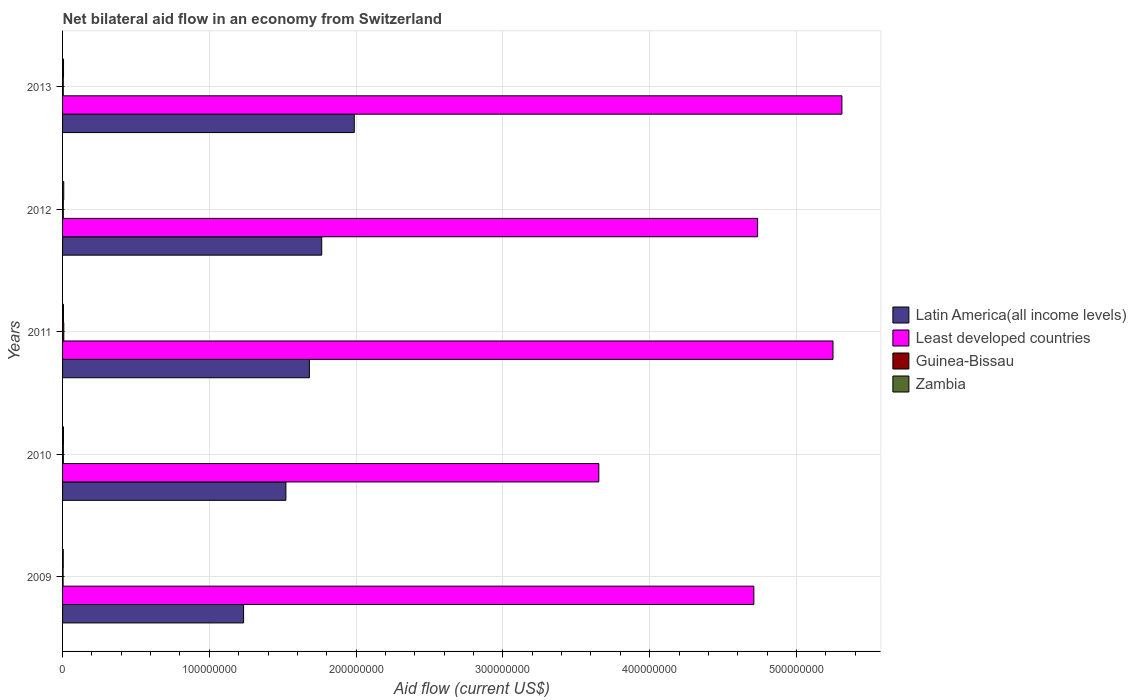How many groups of bars are there?
Your answer should be very brief. 5. Are the number of bars per tick equal to the number of legend labels?
Your answer should be compact. Yes. How many bars are there on the 5th tick from the top?
Keep it short and to the point. 4. How many bars are there on the 1st tick from the bottom?
Provide a short and direct response. 4. What is the label of the 1st group of bars from the top?
Provide a succinct answer. 2013. What is the net bilateral aid flow in Least developed countries in 2009?
Provide a succinct answer. 4.71e+08. Across all years, what is the maximum net bilateral aid flow in Zambia?
Keep it short and to the point. 8.10e+05. Across all years, what is the minimum net bilateral aid flow in Least developed countries?
Give a very brief answer. 3.65e+08. In which year was the net bilateral aid flow in Least developed countries maximum?
Ensure brevity in your answer.  2013. What is the total net bilateral aid flow in Latin America(all income levels) in the graph?
Your response must be concise. 8.19e+08. What is the difference between the net bilateral aid flow in Least developed countries in 2009 and that in 2010?
Keep it short and to the point. 1.06e+08. What is the difference between the net bilateral aid flow in Guinea-Bissau in 2011 and the net bilateral aid flow in Latin America(all income levels) in 2012?
Offer a terse response. -1.76e+08. What is the average net bilateral aid flow in Least developed countries per year?
Offer a very short reply. 4.73e+08. In the year 2009, what is the difference between the net bilateral aid flow in Least developed countries and net bilateral aid flow in Zambia?
Your answer should be compact. 4.71e+08. In how many years, is the net bilateral aid flow in Least developed countries greater than 120000000 US$?
Keep it short and to the point. 5. What is the ratio of the net bilateral aid flow in Latin America(all income levels) in 2009 to that in 2013?
Make the answer very short. 0.62. Is the net bilateral aid flow in Zambia in 2012 less than that in 2013?
Offer a terse response. No. Is the difference between the net bilateral aid flow in Least developed countries in 2010 and 2012 greater than the difference between the net bilateral aid flow in Zambia in 2010 and 2012?
Provide a short and direct response. No. What is the difference between the highest and the second highest net bilateral aid flow in Guinea-Bissau?
Provide a succinct answer. 3.10e+05. In how many years, is the net bilateral aid flow in Latin America(all income levels) greater than the average net bilateral aid flow in Latin America(all income levels) taken over all years?
Provide a short and direct response. 3. Is the sum of the net bilateral aid flow in Least developed countries in 2009 and 2010 greater than the maximum net bilateral aid flow in Guinea-Bissau across all years?
Provide a succinct answer. Yes. Is it the case that in every year, the sum of the net bilateral aid flow in Latin America(all income levels) and net bilateral aid flow in Zambia is greater than the sum of net bilateral aid flow in Guinea-Bissau and net bilateral aid flow in Least developed countries?
Ensure brevity in your answer.  Yes. What does the 4th bar from the top in 2010 represents?
Ensure brevity in your answer.  Latin America(all income levels). What does the 2nd bar from the bottom in 2011 represents?
Provide a short and direct response. Least developed countries. Is it the case that in every year, the sum of the net bilateral aid flow in Zambia and net bilateral aid flow in Guinea-Bissau is greater than the net bilateral aid flow in Latin America(all income levels)?
Give a very brief answer. No. What is the difference between two consecutive major ticks on the X-axis?
Give a very brief answer. 1.00e+08. Does the graph contain grids?
Ensure brevity in your answer.  Yes. Where does the legend appear in the graph?
Your response must be concise. Center right. How many legend labels are there?
Ensure brevity in your answer.  4. What is the title of the graph?
Your response must be concise. Net bilateral aid flow in an economy from Switzerland. What is the Aid flow (current US$) in Latin America(all income levels) in 2009?
Your response must be concise. 1.23e+08. What is the Aid flow (current US$) of Least developed countries in 2009?
Your answer should be very brief. 4.71e+08. What is the Aid flow (current US$) in Guinea-Bissau in 2009?
Make the answer very short. 3.50e+05. What is the Aid flow (current US$) in Latin America(all income levels) in 2010?
Provide a short and direct response. 1.52e+08. What is the Aid flow (current US$) in Least developed countries in 2010?
Your answer should be compact. 3.65e+08. What is the Aid flow (current US$) of Guinea-Bissau in 2010?
Offer a very short reply. 5.30e+05. What is the Aid flow (current US$) of Latin America(all income levels) in 2011?
Ensure brevity in your answer.  1.68e+08. What is the Aid flow (current US$) in Least developed countries in 2011?
Provide a succinct answer. 5.25e+08. What is the Aid flow (current US$) of Guinea-Bissau in 2011?
Make the answer very short. 8.40e+05. What is the Aid flow (current US$) of Zambia in 2011?
Your response must be concise. 6.20e+05. What is the Aid flow (current US$) of Latin America(all income levels) in 2012?
Provide a short and direct response. 1.77e+08. What is the Aid flow (current US$) in Least developed countries in 2012?
Your response must be concise. 4.74e+08. What is the Aid flow (current US$) in Guinea-Bissau in 2012?
Offer a terse response. 4.90e+05. What is the Aid flow (current US$) of Zambia in 2012?
Keep it short and to the point. 8.10e+05. What is the Aid flow (current US$) in Latin America(all income levels) in 2013?
Your answer should be compact. 1.99e+08. What is the Aid flow (current US$) of Least developed countries in 2013?
Provide a short and direct response. 5.31e+08. What is the Aid flow (current US$) in Zambia in 2013?
Offer a very short reply. 6.60e+05. Across all years, what is the maximum Aid flow (current US$) of Latin America(all income levels)?
Your answer should be compact. 1.99e+08. Across all years, what is the maximum Aid flow (current US$) of Least developed countries?
Make the answer very short. 5.31e+08. Across all years, what is the maximum Aid flow (current US$) in Guinea-Bissau?
Give a very brief answer. 8.40e+05. Across all years, what is the maximum Aid flow (current US$) in Zambia?
Give a very brief answer. 8.10e+05. Across all years, what is the minimum Aid flow (current US$) of Latin America(all income levels)?
Ensure brevity in your answer.  1.23e+08. Across all years, what is the minimum Aid flow (current US$) of Least developed countries?
Provide a succinct answer. 3.65e+08. Across all years, what is the minimum Aid flow (current US$) in Zambia?
Give a very brief answer. 4.70e+05. What is the total Aid flow (current US$) in Latin America(all income levels) in the graph?
Give a very brief answer. 8.19e+08. What is the total Aid flow (current US$) in Least developed countries in the graph?
Give a very brief answer. 2.37e+09. What is the total Aid flow (current US$) of Guinea-Bissau in the graph?
Give a very brief answer. 2.68e+06. What is the total Aid flow (current US$) in Zambia in the graph?
Keep it short and to the point. 3.17e+06. What is the difference between the Aid flow (current US$) in Latin America(all income levels) in 2009 and that in 2010?
Your response must be concise. -2.88e+07. What is the difference between the Aid flow (current US$) of Least developed countries in 2009 and that in 2010?
Your response must be concise. 1.06e+08. What is the difference between the Aid flow (current US$) of Zambia in 2009 and that in 2010?
Give a very brief answer. -1.40e+05. What is the difference between the Aid flow (current US$) of Latin America(all income levels) in 2009 and that in 2011?
Your answer should be very brief. -4.48e+07. What is the difference between the Aid flow (current US$) in Least developed countries in 2009 and that in 2011?
Make the answer very short. -5.39e+07. What is the difference between the Aid flow (current US$) in Guinea-Bissau in 2009 and that in 2011?
Give a very brief answer. -4.90e+05. What is the difference between the Aid flow (current US$) of Zambia in 2009 and that in 2011?
Provide a succinct answer. -1.50e+05. What is the difference between the Aid flow (current US$) of Latin America(all income levels) in 2009 and that in 2012?
Your answer should be compact. -5.32e+07. What is the difference between the Aid flow (current US$) of Least developed countries in 2009 and that in 2012?
Give a very brief answer. -2.56e+06. What is the difference between the Aid flow (current US$) in Guinea-Bissau in 2009 and that in 2012?
Your response must be concise. -1.40e+05. What is the difference between the Aid flow (current US$) of Latin America(all income levels) in 2009 and that in 2013?
Your answer should be very brief. -7.54e+07. What is the difference between the Aid flow (current US$) in Least developed countries in 2009 and that in 2013?
Make the answer very short. -6.00e+07. What is the difference between the Aid flow (current US$) in Zambia in 2009 and that in 2013?
Make the answer very short. -1.90e+05. What is the difference between the Aid flow (current US$) in Latin America(all income levels) in 2010 and that in 2011?
Ensure brevity in your answer.  -1.60e+07. What is the difference between the Aid flow (current US$) of Least developed countries in 2010 and that in 2011?
Your answer should be compact. -1.60e+08. What is the difference between the Aid flow (current US$) in Guinea-Bissau in 2010 and that in 2011?
Your response must be concise. -3.10e+05. What is the difference between the Aid flow (current US$) in Latin America(all income levels) in 2010 and that in 2012?
Your answer should be very brief. -2.44e+07. What is the difference between the Aid flow (current US$) in Least developed countries in 2010 and that in 2012?
Provide a succinct answer. -1.08e+08. What is the difference between the Aid flow (current US$) in Zambia in 2010 and that in 2012?
Provide a short and direct response. -2.00e+05. What is the difference between the Aid flow (current US$) in Latin America(all income levels) in 2010 and that in 2013?
Provide a succinct answer. -4.66e+07. What is the difference between the Aid flow (current US$) of Least developed countries in 2010 and that in 2013?
Provide a short and direct response. -1.66e+08. What is the difference between the Aid flow (current US$) of Guinea-Bissau in 2010 and that in 2013?
Give a very brief answer. 6.00e+04. What is the difference between the Aid flow (current US$) in Zambia in 2010 and that in 2013?
Make the answer very short. -5.00e+04. What is the difference between the Aid flow (current US$) in Latin America(all income levels) in 2011 and that in 2012?
Offer a terse response. -8.41e+06. What is the difference between the Aid flow (current US$) of Least developed countries in 2011 and that in 2012?
Provide a short and direct response. 5.14e+07. What is the difference between the Aid flow (current US$) in Latin America(all income levels) in 2011 and that in 2013?
Make the answer very short. -3.06e+07. What is the difference between the Aid flow (current US$) of Least developed countries in 2011 and that in 2013?
Your answer should be compact. -6.06e+06. What is the difference between the Aid flow (current US$) of Guinea-Bissau in 2011 and that in 2013?
Keep it short and to the point. 3.70e+05. What is the difference between the Aid flow (current US$) of Latin America(all income levels) in 2012 and that in 2013?
Ensure brevity in your answer.  -2.22e+07. What is the difference between the Aid flow (current US$) in Least developed countries in 2012 and that in 2013?
Provide a succinct answer. -5.74e+07. What is the difference between the Aid flow (current US$) in Latin America(all income levels) in 2009 and the Aid flow (current US$) in Least developed countries in 2010?
Offer a very short reply. -2.42e+08. What is the difference between the Aid flow (current US$) of Latin America(all income levels) in 2009 and the Aid flow (current US$) of Guinea-Bissau in 2010?
Provide a succinct answer. 1.23e+08. What is the difference between the Aid flow (current US$) in Latin America(all income levels) in 2009 and the Aid flow (current US$) in Zambia in 2010?
Give a very brief answer. 1.23e+08. What is the difference between the Aid flow (current US$) in Least developed countries in 2009 and the Aid flow (current US$) in Guinea-Bissau in 2010?
Give a very brief answer. 4.70e+08. What is the difference between the Aid flow (current US$) in Least developed countries in 2009 and the Aid flow (current US$) in Zambia in 2010?
Your response must be concise. 4.70e+08. What is the difference between the Aid flow (current US$) in Latin America(all income levels) in 2009 and the Aid flow (current US$) in Least developed countries in 2011?
Give a very brief answer. -4.02e+08. What is the difference between the Aid flow (current US$) in Latin America(all income levels) in 2009 and the Aid flow (current US$) in Guinea-Bissau in 2011?
Your response must be concise. 1.22e+08. What is the difference between the Aid flow (current US$) of Latin America(all income levels) in 2009 and the Aid flow (current US$) of Zambia in 2011?
Offer a very short reply. 1.23e+08. What is the difference between the Aid flow (current US$) of Least developed countries in 2009 and the Aid flow (current US$) of Guinea-Bissau in 2011?
Offer a very short reply. 4.70e+08. What is the difference between the Aid flow (current US$) in Least developed countries in 2009 and the Aid flow (current US$) in Zambia in 2011?
Your response must be concise. 4.70e+08. What is the difference between the Aid flow (current US$) of Guinea-Bissau in 2009 and the Aid flow (current US$) of Zambia in 2011?
Keep it short and to the point. -2.70e+05. What is the difference between the Aid flow (current US$) in Latin America(all income levels) in 2009 and the Aid flow (current US$) in Least developed countries in 2012?
Provide a short and direct response. -3.50e+08. What is the difference between the Aid flow (current US$) in Latin America(all income levels) in 2009 and the Aid flow (current US$) in Guinea-Bissau in 2012?
Your response must be concise. 1.23e+08. What is the difference between the Aid flow (current US$) of Latin America(all income levels) in 2009 and the Aid flow (current US$) of Zambia in 2012?
Provide a succinct answer. 1.23e+08. What is the difference between the Aid flow (current US$) in Least developed countries in 2009 and the Aid flow (current US$) in Guinea-Bissau in 2012?
Offer a terse response. 4.71e+08. What is the difference between the Aid flow (current US$) of Least developed countries in 2009 and the Aid flow (current US$) of Zambia in 2012?
Provide a short and direct response. 4.70e+08. What is the difference between the Aid flow (current US$) of Guinea-Bissau in 2009 and the Aid flow (current US$) of Zambia in 2012?
Your answer should be compact. -4.60e+05. What is the difference between the Aid flow (current US$) in Latin America(all income levels) in 2009 and the Aid flow (current US$) in Least developed countries in 2013?
Provide a short and direct response. -4.08e+08. What is the difference between the Aid flow (current US$) in Latin America(all income levels) in 2009 and the Aid flow (current US$) in Guinea-Bissau in 2013?
Keep it short and to the point. 1.23e+08. What is the difference between the Aid flow (current US$) in Latin America(all income levels) in 2009 and the Aid flow (current US$) in Zambia in 2013?
Provide a short and direct response. 1.23e+08. What is the difference between the Aid flow (current US$) of Least developed countries in 2009 and the Aid flow (current US$) of Guinea-Bissau in 2013?
Ensure brevity in your answer.  4.71e+08. What is the difference between the Aid flow (current US$) in Least developed countries in 2009 and the Aid flow (current US$) in Zambia in 2013?
Make the answer very short. 4.70e+08. What is the difference between the Aid flow (current US$) of Guinea-Bissau in 2009 and the Aid flow (current US$) of Zambia in 2013?
Your answer should be compact. -3.10e+05. What is the difference between the Aid flow (current US$) of Latin America(all income levels) in 2010 and the Aid flow (current US$) of Least developed countries in 2011?
Keep it short and to the point. -3.73e+08. What is the difference between the Aid flow (current US$) of Latin America(all income levels) in 2010 and the Aid flow (current US$) of Guinea-Bissau in 2011?
Offer a very short reply. 1.51e+08. What is the difference between the Aid flow (current US$) of Latin America(all income levels) in 2010 and the Aid flow (current US$) of Zambia in 2011?
Offer a very short reply. 1.52e+08. What is the difference between the Aid flow (current US$) in Least developed countries in 2010 and the Aid flow (current US$) in Guinea-Bissau in 2011?
Keep it short and to the point. 3.65e+08. What is the difference between the Aid flow (current US$) in Least developed countries in 2010 and the Aid flow (current US$) in Zambia in 2011?
Offer a very short reply. 3.65e+08. What is the difference between the Aid flow (current US$) in Guinea-Bissau in 2010 and the Aid flow (current US$) in Zambia in 2011?
Ensure brevity in your answer.  -9.00e+04. What is the difference between the Aid flow (current US$) of Latin America(all income levels) in 2010 and the Aid flow (current US$) of Least developed countries in 2012?
Your response must be concise. -3.21e+08. What is the difference between the Aid flow (current US$) in Latin America(all income levels) in 2010 and the Aid flow (current US$) in Guinea-Bissau in 2012?
Offer a very short reply. 1.52e+08. What is the difference between the Aid flow (current US$) in Latin America(all income levels) in 2010 and the Aid flow (current US$) in Zambia in 2012?
Make the answer very short. 1.51e+08. What is the difference between the Aid flow (current US$) in Least developed countries in 2010 and the Aid flow (current US$) in Guinea-Bissau in 2012?
Give a very brief answer. 3.65e+08. What is the difference between the Aid flow (current US$) of Least developed countries in 2010 and the Aid flow (current US$) of Zambia in 2012?
Your answer should be compact. 3.65e+08. What is the difference between the Aid flow (current US$) of Guinea-Bissau in 2010 and the Aid flow (current US$) of Zambia in 2012?
Give a very brief answer. -2.80e+05. What is the difference between the Aid flow (current US$) of Latin America(all income levels) in 2010 and the Aid flow (current US$) of Least developed countries in 2013?
Provide a succinct answer. -3.79e+08. What is the difference between the Aid flow (current US$) in Latin America(all income levels) in 2010 and the Aid flow (current US$) in Guinea-Bissau in 2013?
Make the answer very short. 1.52e+08. What is the difference between the Aid flow (current US$) in Latin America(all income levels) in 2010 and the Aid flow (current US$) in Zambia in 2013?
Offer a terse response. 1.52e+08. What is the difference between the Aid flow (current US$) in Least developed countries in 2010 and the Aid flow (current US$) in Guinea-Bissau in 2013?
Ensure brevity in your answer.  3.65e+08. What is the difference between the Aid flow (current US$) in Least developed countries in 2010 and the Aid flow (current US$) in Zambia in 2013?
Your answer should be very brief. 3.65e+08. What is the difference between the Aid flow (current US$) of Latin America(all income levels) in 2011 and the Aid flow (current US$) of Least developed countries in 2012?
Provide a succinct answer. -3.05e+08. What is the difference between the Aid flow (current US$) in Latin America(all income levels) in 2011 and the Aid flow (current US$) in Guinea-Bissau in 2012?
Provide a succinct answer. 1.68e+08. What is the difference between the Aid flow (current US$) in Latin America(all income levels) in 2011 and the Aid flow (current US$) in Zambia in 2012?
Give a very brief answer. 1.67e+08. What is the difference between the Aid flow (current US$) of Least developed countries in 2011 and the Aid flow (current US$) of Guinea-Bissau in 2012?
Provide a short and direct response. 5.24e+08. What is the difference between the Aid flow (current US$) of Least developed countries in 2011 and the Aid flow (current US$) of Zambia in 2012?
Keep it short and to the point. 5.24e+08. What is the difference between the Aid flow (current US$) of Guinea-Bissau in 2011 and the Aid flow (current US$) of Zambia in 2012?
Offer a very short reply. 3.00e+04. What is the difference between the Aid flow (current US$) in Latin America(all income levels) in 2011 and the Aid flow (current US$) in Least developed countries in 2013?
Provide a succinct answer. -3.63e+08. What is the difference between the Aid flow (current US$) in Latin America(all income levels) in 2011 and the Aid flow (current US$) in Guinea-Bissau in 2013?
Give a very brief answer. 1.68e+08. What is the difference between the Aid flow (current US$) of Latin America(all income levels) in 2011 and the Aid flow (current US$) of Zambia in 2013?
Ensure brevity in your answer.  1.68e+08. What is the difference between the Aid flow (current US$) of Least developed countries in 2011 and the Aid flow (current US$) of Guinea-Bissau in 2013?
Offer a very short reply. 5.24e+08. What is the difference between the Aid flow (current US$) in Least developed countries in 2011 and the Aid flow (current US$) in Zambia in 2013?
Offer a very short reply. 5.24e+08. What is the difference between the Aid flow (current US$) in Guinea-Bissau in 2011 and the Aid flow (current US$) in Zambia in 2013?
Your answer should be compact. 1.80e+05. What is the difference between the Aid flow (current US$) in Latin America(all income levels) in 2012 and the Aid flow (current US$) in Least developed countries in 2013?
Provide a short and direct response. -3.54e+08. What is the difference between the Aid flow (current US$) in Latin America(all income levels) in 2012 and the Aid flow (current US$) in Guinea-Bissau in 2013?
Your answer should be very brief. 1.76e+08. What is the difference between the Aid flow (current US$) of Latin America(all income levels) in 2012 and the Aid flow (current US$) of Zambia in 2013?
Your answer should be very brief. 1.76e+08. What is the difference between the Aid flow (current US$) in Least developed countries in 2012 and the Aid flow (current US$) in Guinea-Bissau in 2013?
Give a very brief answer. 4.73e+08. What is the difference between the Aid flow (current US$) of Least developed countries in 2012 and the Aid flow (current US$) of Zambia in 2013?
Ensure brevity in your answer.  4.73e+08. What is the difference between the Aid flow (current US$) in Guinea-Bissau in 2012 and the Aid flow (current US$) in Zambia in 2013?
Give a very brief answer. -1.70e+05. What is the average Aid flow (current US$) in Latin America(all income levels) per year?
Ensure brevity in your answer.  1.64e+08. What is the average Aid flow (current US$) of Least developed countries per year?
Ensure brevity in your answer.  4.73e+08. What is the average Aid flow (current US$) of Guinea-Bissau per year?
Offer a very short reply. 5.36e+05. What is the average Aid flow (current US$) in Zambia per year?
Ensure brevity in your answer.  6.34e+05. In the year 2009, what is the difference between the Aid flow (current US$) of Latin America(all income levels) and Aid flow (current US$) of Least developed countries?
Offer a very short reply. -3.48e+08. In the year 2009, what is the difference between the Aid flow (current US$) in Latin America(all income levels) and Aid flow (current US$) in Guinea-Bissau?
Provide a succinct answer. 1.23e+08. In the year 2009, what is the difference between the Aid flow (current US$) of Latin America(all income levels) and Aid flow (current US$) of Zambia?
Offer a very short reply. 1.23e+08. In the year 2009, what is the difference between the Aid flow (current US$) of Least developed countries and Aid flow (current US$) of Guinea-Bissau?
Keep it short and to the point. 4.71e+08. In the year 2009, what is the difference between the Aid flow (current US$) in Least developed countries and Aid flow (current US$) in Zambia?
Provide a succinct answer. 4.71e+08. In the year 2010, what is the difference between the Aid flow (current US$) in Latin America(all income levels) and Aid flow (current US$) in Least developed countries?
Your answer should be very brief. -2.13e+08. In the year 2010, what is the difference between the Aid flow (current US$) in Latin America(all income levels) and Aid flow (current US$) in Guinea-Bissau?
Keep it short and to the point. 1.52e+08. In the year 2010, what is the difference between the Aid flow (current US$) of Latin America(all income levels) and Aid flow (current US$) of Zambia?
Ensure brevity in your answer.  1.52e+08. In the year 2010, what is the difference between the Aid flow (current US$) in Least developed countries and Aid flow (current US$) in Guinea-Bissau?
Keep it short and to the point. 3.65e+08. In the year 2010, what is the difference between the Aid flow (current US$) in Least developed countries and Aid flow (current US$) in Zambia?
Offer a very short reply. 3.65e+08. In the year 2011, what is the difference between the Aid flow (current US$) of Latin America(all income levels) and Aid flow (current US$) of Least developed countries?
Ensure brevity in your answer.  -3.57e+08. In the year 2011, what is the difference between the Aid flow (current US$) of Latin America(all income levels) and Aid flow (current US$) of Guinea-Bissau?
Provide a short and direct response. 1.67e+08. In the year 2011, what is the difference between the Aid flow (current US$) of Latin America(all income levels) and Aid flow (current US$) of Zambia?
Make the answer very short. 1.68e+08. In the year 2011, what is the difference between the Aid flow (current US$) of Least developed countries and Aid flow (current US$) of Guinea-Bissau?
Provide a succinct answer. 5.24e+08. In the year 2011, what is the difference between the Aid flow (current US$) of Least developed countries and Aid flow (current US$) of Zambia?
Your answer should be compact. 5.24e+08. In the year 2012, what is the difference between the Aid flow (current US$) of Latin America(all income levels) and Aid flow (current US$) of Least developed countries?
Ensure brevity in your answer.  -2.97e+08. In the year 2012, what is the difference between the Aid flow (current US$) of Latin America(all income levels) and Aid flow (current US$) of Guinea-Bissau?
Offer a terse response. 1.76e+08. In the year 2012, what is the difference between the Aid flow (current US$) in Latin America(all income levels) and Aid flow (current US$) in Zambia?
Offer a terse response. 1.76e+08. In the year 2012, what is the difference between the Aid flow (current US$) in Least developed countries and Aid flow (current US$) in Guinea-Bissau?
Ensure brevity in your answer.  4.73e+08. In the year 2012, what is the difference between the Aid flow (current US$) of Least developed countries and Aid flow (current US$) of Zambia?
Your answer should be very brief. 4.73e+08. In the year 2012, what is the difference between the Aid flow (current US$) in Guinea-Bissau and Aid flow (current US$) in Zambia?
Provide a short and direct response. -3.20e+05. In the year 2013, what is the difference between the Aid flow (current US$) in Latin America(all income levels) and Aid flow (current US$) in Least developed countries?
Your answer should be very brief. -3.32e+08. In the year 2013, what is the difference between the Aid flow (current US$) of Latin America(all income levels) and Aid flow (current US$) of Guinea-Bissau?
Make the answer very short. 1.98e+08. In the year 2013, what is the difference between the Aid flow (current US$) in Latin America(all income levels) and Aid flow (current US$) in Zambia?
Offer a very short reply. 1.98e+08. In the year 2013, what is the difference between the Aid flow (current US$) of Least developed countries and Aid flow (current US$) of Guinea-Bissau?
Provide a succinct answer. 5.31e+08. In the year 2013, what is the difference between the Aid flow (current US$) of Least developed countries and Aid flow (current US$) of Zambia?
Provide a short and direct response. 5.30e+08. In the year 2013, what is the difference between the Aid flow (current US$) of Guinea-Bissau and Aid flow (current US$) of Zambia?
Provide a succinct answer. -1.90e+05. What is the ratio of the Aid flow (current US$) in Latin America(all income levels) in 2009 to that in 2010?
Your answer should be compact. 0.81. What is the ratio of the Aid flow (current US$) in Least developed countries in 2009 to that in 2010?
Offer a very short reply. 1.29. What is the ratio of the Aid flow (current US$) of Guinea-Bissau in 2009 to that in 2010?
Your answer should be compact. 0.66. What is the ratio of the Aid flow (current US$) of Zambia in 2009 to that in 2010?
Ensure brevity in your answer.  0.77. What is the ratio of the Aid flow (current US$) in Latin America(all income levels) in 2009 to that in 2011?
Give a very brief answer. 0.73. What is the ratio of the Aid flow (current US$) in Least developed countries in 2009 to that in 2011?
Offer a terse response. 0.9. What is the ratio of the Aid flow (current US$) of Guinea-Bissau in 2009 to that in 2011?
Your response must be concise. 0.42. What is the ratio of the Aid flow (current US$) of Zambia in 2009 to that in 2011?
Give a very brief answer. 0.76. What is the ratio of the Aid flow (current US$) of Latin America(all income levels) in 2009 to that in 2012?
Your answer should be very brief. 0.7. What is the ratio of the Aid flow (current US$) in Least developed countries in 2009 to that in 2012?
Provide a short and direct response. 0.99. What is the ratio of the Aid flow (current US$) in Zambia in 2009 to that in 2012?
Offer a terse response. 0.58. What is the ratio of the Aid flow (current US$) of Latin America(all income levels) in 2009 to that in 2013?
Your answer should be very brief. 0.62. What is the ratio of the Aid flow (current US$) of Least developed countries in 2009 to that in 2013?
Ensure brevity in your answer.  0.89. What is the ratio of the Aid flow (current US$) of Guinea-Bissau in 2009 to that in 2013?
Make the answer very short. 0.74. What is the ratio of the Aid flow (current US$) in Zambia in 2009 to that in 2013?
Offer a very short reply. 0.71. What is the ratio of the Aid flow (current US$) in Latin America(all income levels) in 2010 to that in 2011?
Your answer should be very brief. 0.9. What is the ratio of the Aid flow (current US$) in Least developed countries in 2010 to that in 2011?
Your answer should be compact. 0.7. What is the ratio of the Aid flow (current US$) in Guinea-Bissau in 2010 to that in 2011?
Offer a very short reply. 0.63. What is the ratio of the Aid flow (current US$) of Zambia in 2010 to that in 2011?
Your answer should be compact. 0.98. What is the ratio of the Aid flow (current US$) in Latin America(all income levels) in 2010 to that in 2012?
Your response must be concise. 0.86. What is the ratio of the Aid flow (current US$) of Least developed countries in 2010 to that in 2012?
Provide a succinct answer. 0.77. What is the ratio of the Aid flow (current US$) in Guinea-Bissau in 2010 to that in 2012?
Keep it short and to the point. 1.08. What is the ratio of the Aid flow (current US$) of Zambia in 2010 to that in 2012?
Your response must be concise. 0.75. What is the ratio of the Aid flow (current US$) in Latin America(all income levels) in 2010 to that in 2013?
Your response must be concise. 0.77. What is the ratio of the Aid flow (current US$) in Least developed countries in 2010 to that in 2013?
Offer a very short reply. 0.69. What is the ratio of the Aid flow (current US$) in Guinea-Bissau in 2010 to that in 2013?
Keep it short and to the point. 1.13. What is the ratio of the Aid flow (current US$) of Zambia in 2010 to that in 2013?
Your response must be concise. 0.92. What is the ratio of the Aid flow (current US$) of Latin America(all income levels) in 2011 to that in 2012?
Keep it short and to the point. 0.95. What is the ratio of the Aid flow (current US$) of Least developed countries in 2011 to that in 2012?
Give a very brief answer. 1.11. What is the ratio of the Aid flow (current US$) in Guinea-Bissau in 2011 to that in 2012?
Ensure brevity in your answer.  1.71. What is the ratio of the Aid flow (current US$) in Zambia in 2011 to that in 2012?
Provide a succinct answer. 0.77. What is the ratio of the Aid flow (current US$) of Latin America(all income levels) in 2011 to that in 2013?
Make the answer very short. 0.85. What is the ratio of the Aid flow (current US$) of Guinea-Bissau in 2011 to that in 2013?
Your response must be concise. 1.79. What is the ratio of the Aid flow (current US$) of Zambia in 2011 to that in 2013?
Your response must be concise. 0.94. What is the ratio of the Aid flow (current US$) of Latin America(all income levels) in 2012 to that in 2013?
Make the answer very short. 0.89. What is the ratio of the Aid flow (current US$) of Least developed countries in 2012 to that in 2013?
Your answer should be compact. 0.89. What is the ratio of the Aid flow (current US$) in Guinea-Bissau in 2012 to that in 2013?
Provide a succinct answer. 1.04. What is the ratio of the Aid flow (current US$) in Zambia in 2012 to that in 2013?
Give a very brief answer. 1.23. What is the difference between the highest and the second highest Aid flow (current US$) of Latin America(all income levels)?
Your response must be concise. 2.22e+07. What is the difference between the highest and the second highest Aid flow (current US$) of Least developed countries?
Keep it short and to the point. 6.06e+06. What is the difference between the highest and the second highest Aid flow (current US$) in Zambia?
Provide a short and direct response. 1.50e+05. What is the difference between the highest and the lowest Aid flow (current US$) in Latin America(all income levels)?
Your answer should be very brief. 7.54e+07. What is the difference between the highest and the lowest Aid flow (current US$) of Least developed countries?
Give a very brief answer. 1.66e+08. What is the difference between the highest and the lowest Aid flow (current US$) in Guinea-Bissau?
Your answer should be very brief. 4.90e+05. What is the difference between the highest and the lowest Aid flow (current US$) in Zambia?
Make the answer very short. 3.40e+05. 